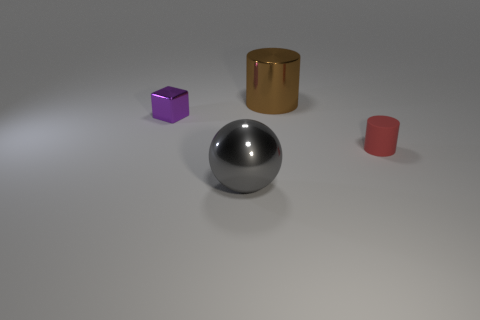What is the color of the other large object that is made of the same material as the gray object?
Your response must be concise. Brown. Is the number of gray shiny cylinders greater than the number of tiny blocks?
Give a very brief answer. No. What number of objects are things to the left of the large gray thing or red cylinders?
Make the answer very short. 2. Are there any purple metallic blocks of the same size as the purple thing?
Your answer should be compact. No. Is the number of big cylinders less than the number of tiny brown metal cylinders?
Your response must be concise. No. What number of balls are big brown metal objects or tiny red objects?
Make the answer very short. 0. What number of big metal cylinders have the same color as the big sphere?
Offer a terse response. 0. How big is the metal object that is right of the purple shiny block and in front of the brown cylinder?
Give a very brief answer. Large. Are there fewer big brown cylinders to the right of the tiny rubber thing than purple metallic objects?
Provide a short and direct response. Yes. Is the material of the big gray thing the same as the small cube?
Ensure brevity in your answer.  Yes. 